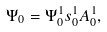<formula> <loc_0><loc_0><loc_500><loc_500>\Psi _ { 0 } = \Psi _ { 0 } ^ { 1 } s _ { 0 } ^ { 1 } A _ { 0 } ^ { 1 } ,</formula> 